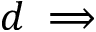Convert formula to latex. <formula><loc_0><loc_0><loc_500><loc_500>d \implies</formula> 